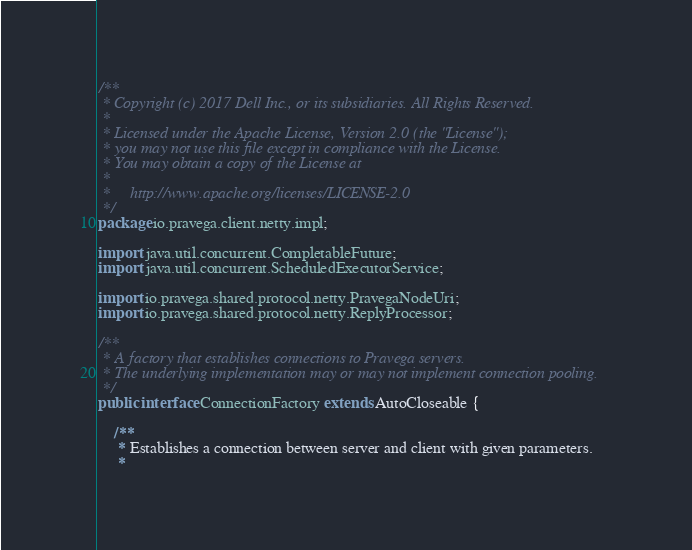Convert code to text. <code><loc_0><loc_0><loc_500><loc_500><_Java_>/**
 * Copyright (c) 2017 Dell Inc., or its subsidiaries. All Rights Reserved.
 *
 * Licensed under the Apache License, Version 2.0 (the "License");
 * you may not use this file except in compliance with the License.
 * You may obtain a copy of the License at
 *
 *     http://www.apache.org/licenses/LICENSE-2.0
 */
package io.pravega.client.netty.impl;

import java.util.concurrent.CompletableFuture;
import java.util.concurrent.ScheduledExecutorService;

import io.pravega.shared.protocol.netty.PravegaNodeUri;
import io.pravega.shared.protocol.netty.ReplyProcessor;

/**
 * A factory that establishes connections to Pravega servers.
 * The underlying implementation may or may not implement connection pooling.
 */
public interface ConnectionFactory extends AutoCloseable {

    /**
     * Establishes a connection between server and client with given parameters.
     *</code> 